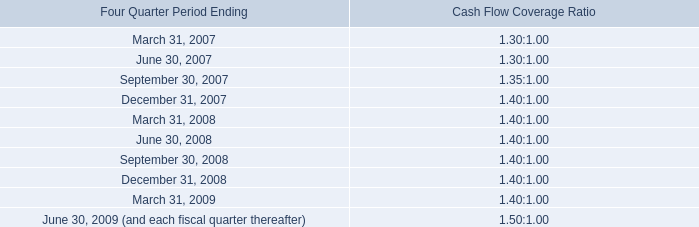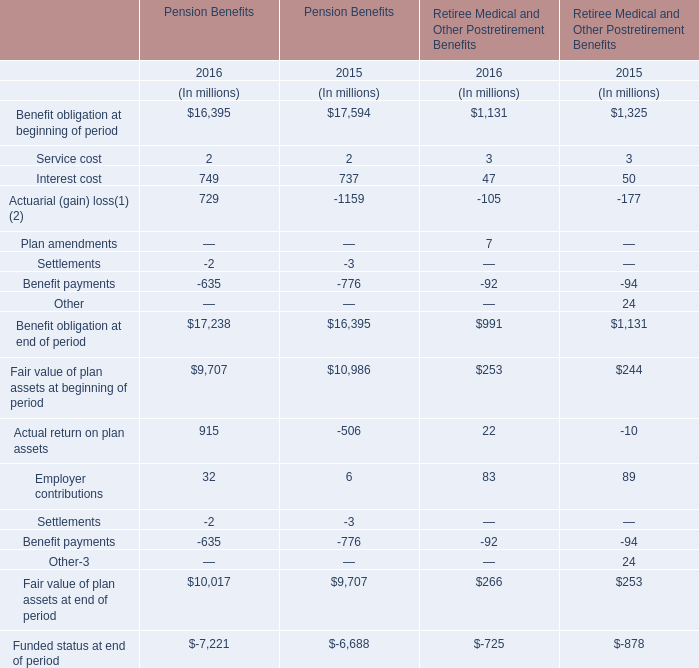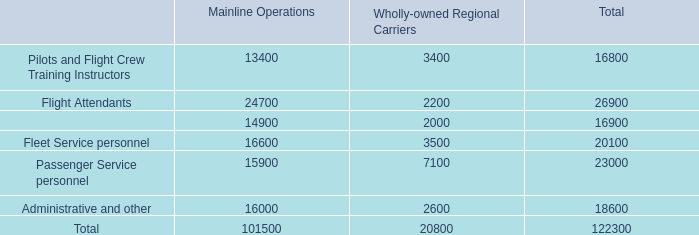What's the average of Pension Benefits' benefit obligation at beginning of period in 2015 and 2016? (in million) 
Computations: ((16395 + 17594) / 2)
Answer: 16994.5. 